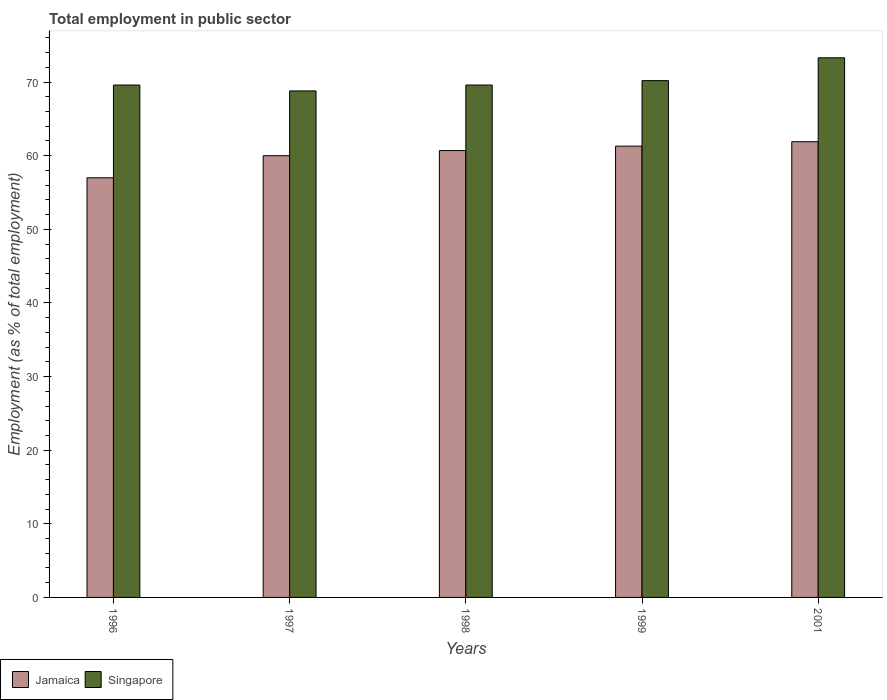How many groups of bars are there?
Provide a short and direct response. 5. Are the number of bars on each tick of the X-axis equal?
Offer a terse response. Yes. How many bars are there on the 4th tick from the right?
Keep it short and to the point. 2. What is the label of the 2nd group of bars from the left?
Offer a terse response. 1997. What is the employment in public sector in Jamaica in 1998?
Your answer should be compact. 60.7. Across all years, what is the maximum employment in public sector in Jamaica?
Your answer should be very brief. 61.9. In which year was the employment in public sector in Singapore minimum?
Offer a terse response. 1997. What is the total employment in public sector in Jamaica in the graph?
Offer a terse response. 300.9. What is the difference between the employment in public sector in Singapore in 1996 and that in 1999?
Provide a short and direct response. -0.6. What is the difference between the employment in public sector in Singapore in 2001 and the employment in public sector in Jamaica in 1996?
Provide a short and direct response. 16.3. What is the average employment in public sector in Singapore per year?
Your answer should be very brief. 70.3. In the year 1998, what is the difference between the employment in public sector in Singapore and employment in public sector in Jamaica?
Your response must be concise. 8.9. What is the ratio of the employment in public sector in Singapore in 1997 to that in 1998?
Offer a terse response. 0.99. Is the employment in public sector in Jamaica in 1997 less than that in 1999?
Make the answer very short. Yes. What is the difference between the highest and the second highest employment in public sector in Singapore?
Make the answer very short. 3.1. What is the difference between the highest and the lowest employment in public sector in Jamaica?
Your response must be concise. 4.9. Is the sum of the employment in public sector in Singapore in 1997 and 1999 greater than the maximum employment in public sector in Jamaica across all years?
Offer a very short reply. Yes. What does the 1st bar from the left in 1997 represents?
Offer a very short reply. Jamaica. What does the 1st bar from the right in 1997 represents?
Keep it short and to the point. Singapore. How many bars are there?
Give a very brief answer. 10. Are all the bars in the graph horizontal?
Your response must be concise. No. What is the difference between two consecutive major ticks on the Y-axis?
Give a very brief answer. 10. Does the graph contain grids?
Make the answer very short. No. Where does the legend appear in the graph?
Offer a terse response. Bottom left. How many legend labels are there?
Give a very brief answer. 2. How are the legend labels stacked?
Offer a very short reply. Horizontal. What is the title of the graph?
Provide a succinct answer. Total employment in public sector. What is the label or title of the X-axis?
Your response must be concise. Years. What is the label or title of the Y-axis?
Ensure brevity in your answer.  Employment (as % of total employment). What is the Employment (as % of total employment) in Jamaica in 1996?
Your answer should be compact. 57. What is the Employment (as % of total employment) of Singapore in 1996?
Ensure brevity in your answer.  69.6. What is the Employment (as % of total employment) in Jamaica in 1997?
Your answer should be very brief. 60. What is the Employment (as % of total employment) in Singapore in 1997?
Provide a succinct answer. 68.8. What is the Employment (as % of total employment) in Jamaica in 1998?
Ensure brevity in your answer.  60.7. What is the Employment (as % of total employment) of Singapore in 1998?
Offer a very short reply. 69.6. What is the Employment (as % of total employment) in Jamaica in 1999?
Your answer should be compact. 61.3. What is the Employment (as % of total employment) in Singapore in 1999?
Provide a succinct answer. 70.2. What is the Employment (as % of total employment) in Jamaica in 2001?
Your answer should be compact. 61.9. What is the Employment (as % of total employment) of Singapore in 2001?
Your response must be concise. 73.3. Across all years, what is the maximum Employment (as % of total employment) of Jamaica?
Provide a short and direct response. 61.9. Across all years, what is the maximum Employment (as % of total employment) in Singapore?
Offer a terse response. 73.3. Across all years, what is the minimum Employment (as % of total employment) of Singapore?
Provide a short and direct response. 68.8. What is the total Employment (as % of total employment) in Jamaica in the graph?
Ensure brevity in your answer.  300.9. What is the total Employment (as % of total employment) of Singapore in the graph?
Your response must be concise. 351.5. What is the difference between the Employment (as % of total employment) in Jamaica in 1996 and that in 1997?
Ensure brevity in your answer.  -3. What is the difference between the Employment (as % of total employment) of Singapore in 1996 and that in 1997?
Make the answer very short. 0.8. What is the difference between the Employment (as % of total employment) of Jamaica in 1996 and that in 1998?
Offer a very short reply. -3.7. What is the difference between the Employment (as % of total employment) of Singapore in 1996 and that in 1999?
Provide a succinct answer. -0.6. What is the difference between the Employment (as % of total employment) in Jamaica in 1997 and that in 1998?
Your response must be concise. -0.7. What is the difference between the Employment (as % of total employment) of Jamaica in 1997 and that in 2001?
Your answer should be compact. -1.9. What is the difference between the Employment (as % of total employment) in Singapore in 1998 and that in 1999?
Your answer should be compact. -0.6. What is the difference between the Employment (as % of total employment) of Jamaica in 1996 and the Employment (as % of total employment) of Singapore in 1997?
Your answer should be compact. -11.8. What is the difference between the Employment (as % of total employment) in Jamaica in 1996 and the Employment (as % of total employment) in Singapore in 1999?
Provide a short and direct response. -13.2. What is the difference between the Employment (as % of total employment) of Jamaica in 1996 and the Employment (as % of total employment) of Singapore in 2001?
Give a very brief answer. -16.3. What is the difference between the Employment (as % of total employment) of Jamaica in 1997 and the Employment (as % of total employment) of Singapore in 1998?
Offer a terse response. -9.6. What is the difference between the Employment (as % of total employment) in Jamaica in 1998 and the Employment (as % of total employment) in Singapore in 1999?
Offer a very short reply. -9.5. What is the difference between the Employment (as % of total employment) of Jamaica in 1998 and the Employment (as % of total employment) of Singapore in 2001?
Ensure brevity in your answer.  -12.6. What is the difference between the Employment (as % of total employment) of Jamaica in 1999 and the Employment (as % of total employment) of Singapore in 2001?
Offer a very short reply. -12. What is the average Employment (as % of total employment) of Jamaica per year?
Offer a very short reply. 60.18. What is the average Employment (as % of total employment) of Singapore per year?
Ensure brevity in your answer.  70.3. In the year 1996, what is the difference between the Employment (as % of total employment) in Jamaica and Employment (as % of total employment) in Singapore?
Provide a short and direct response. -12.6. In the year 1997, what is the difference between the Employment (as % of total employment) of Jamaica and Employment (as % of total employment) of Singapore?
Provide a short and direct response. -8.8. In the year 1998, what is the difference between the Employment (as % of total employment) in Jamaica and Employment (as % of total employment) in Singapore?
Ensure brevity in your answer.  -8.9. In the year 1999, what is the difference between the Employment (as % of total employment) of Jamaica and Employment (as % of total employment) of Singapore?
Give a very brief answer. -8.9. What is the ratio of the Employment (as % of total employment) of Singapore in 1996 to that in 1997?
Give a very brief answer. 1.01. What is the ratio of the Employment (as % of total employment) in Jamaica in 1996 to that in 1998?
Offer a terse response. 0.94. What is the ratio of the Employment (as % of total employment) in Jamaica in 1996 to that in 1999?
Offer a terse response. 0.93. What is the ratio of the Employment (as % of total employment) of Singapore in 1996 to that in 1999?
Keep it short and to the point. 0.99. What is the ratio of the Employment (as % of total employment) of Jamaica in 1996 to that in 2001?
Offer a very short reply. 0.92. What is the ratio of the Employment (as % of total employment) of Singapore in 1996 to that in 2001?
Your answer should be very brief. 0.95. What is the ratio of the Employment (as % of total employment) in Jamaica in 1997 to that in 1998?
Give a very brief answer. 0.99. What is the ratio of the Employment (as % of total employment) in Jamaica in 1997 to that in 1999?
Your answer should be very brief. 0.98. What is the ratio of the Employment (as % of total employment) in Singapore in 1997 to that in 1999?
Provide a short and direct response. 0.98. What is the ratio of the Employment (as % of total employment) in Jamaica in 1997 to that in 2001?
Your answer should be very brief. 0.97. What is the ratio of the Employment (as % of total employment) of Singapore in 1997 to that in 2001?
Ensure brevity in your answer.  0.94. What is the ratio of the Employment (as % of total employment) in Jamaica in 1998 to that in 1999?
Ensure brevity in your answer.  0.99. What is the ratio of the Employment (as % of total employment) in Jamaica in 1998 to that in 2001?
Your response must be concise. 0.98. What is the ratio of the Employment (as % of total employment) in Singapore in 1998 to that in 2001?
Ensure brevity in your answer.  0.95. What is the ratio of the Employment (as % of total employment) of Jamaica in 1999 to that in 2001?
Make the answer very short. 0.99. What is the ratio of the Employment (as % of total employment) of Singapore in 1999 to that in 2001?
Provide a short and direct response. 0.96. What is the difference between the highest and the second highest Employment (as % of total employment) in Jamaica?
Provide a short and direct response. 0.6. What is the difference between the highest and the second highest Employment (as % of total employment) in Singapore?
Give a very brief answer. 3.1. What is the difference between the highest and the lowest Employment (as % of total employment) of Singapore?
Your answer should be compact. 4.5. 